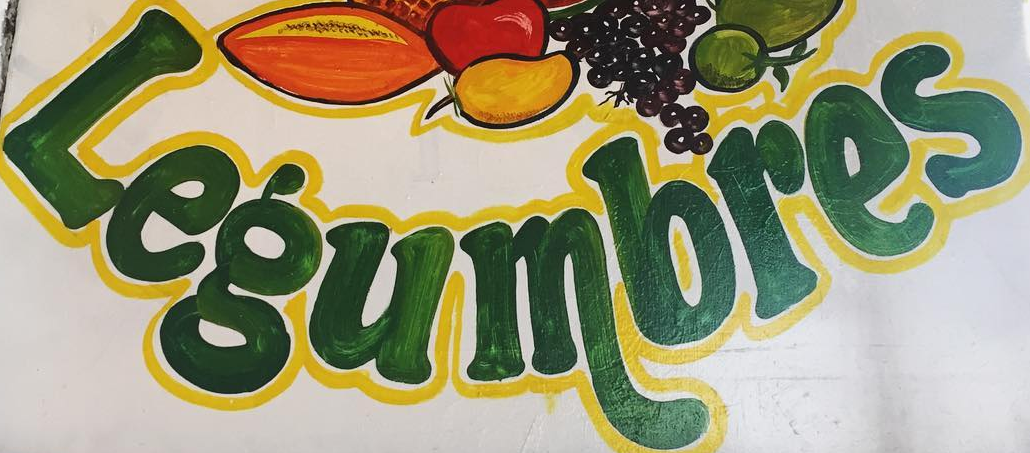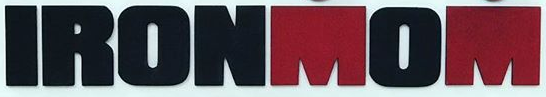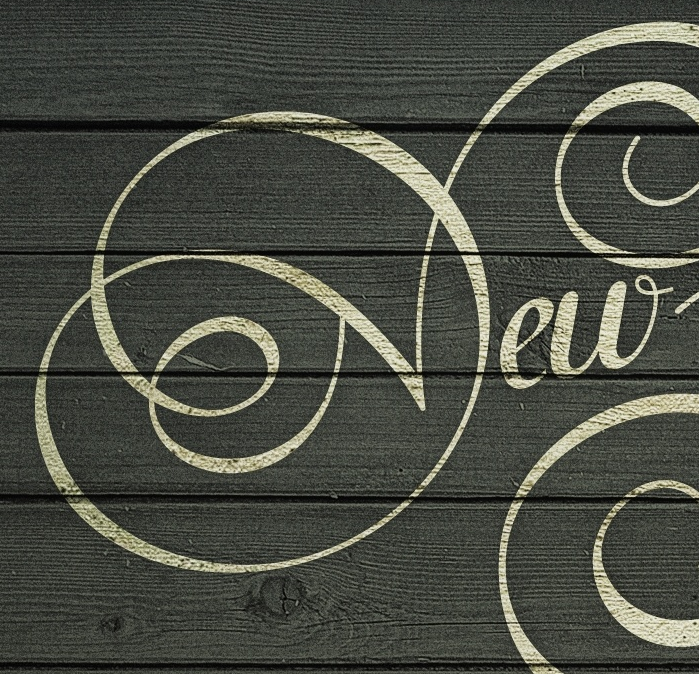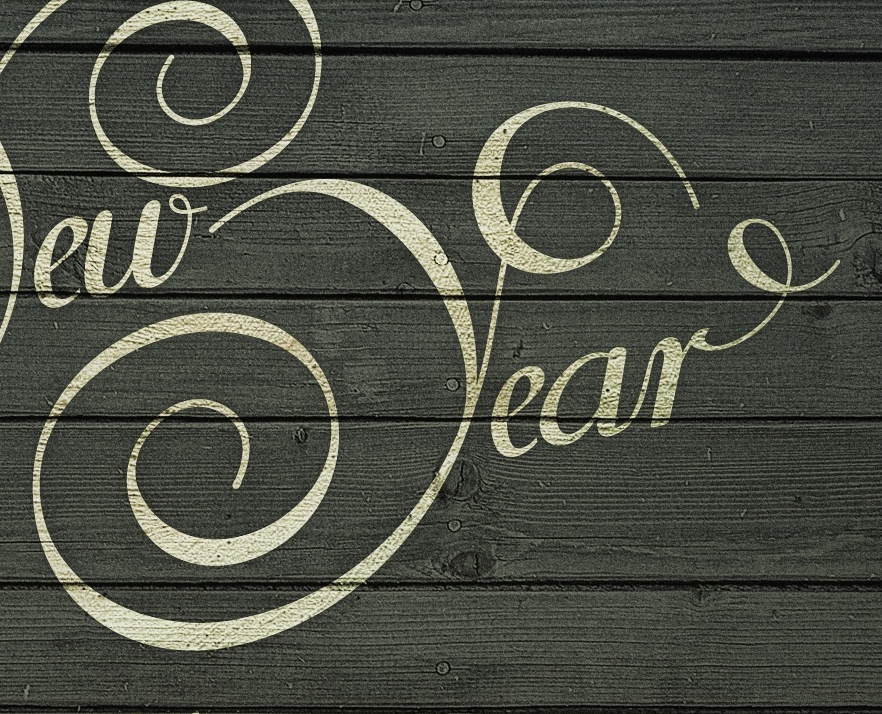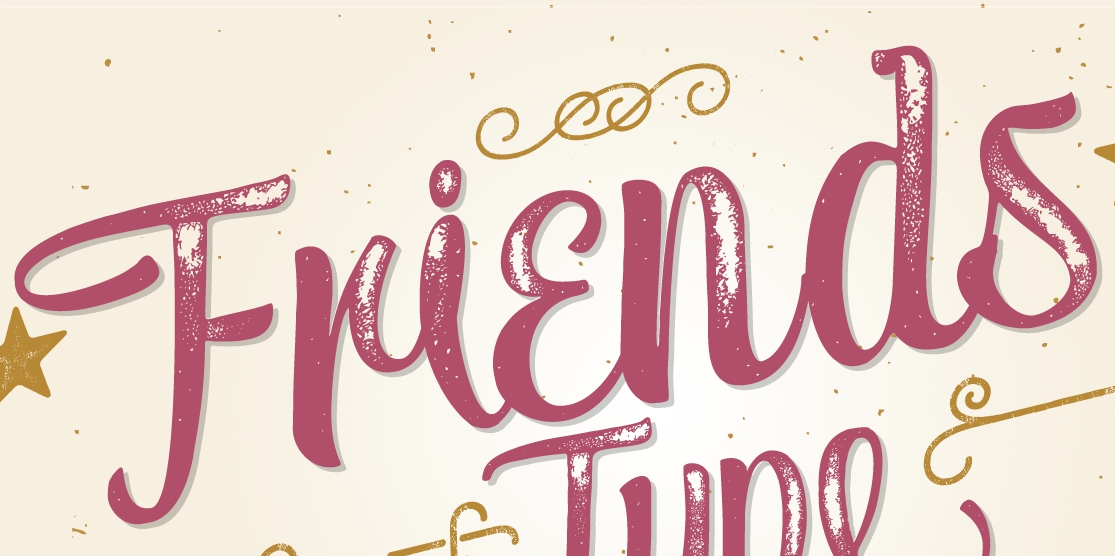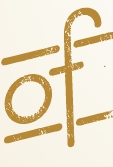What text appears in these images from left to right, separated by a semicolon? Legumbres; IRONMOM; New; Year; Friends; of 